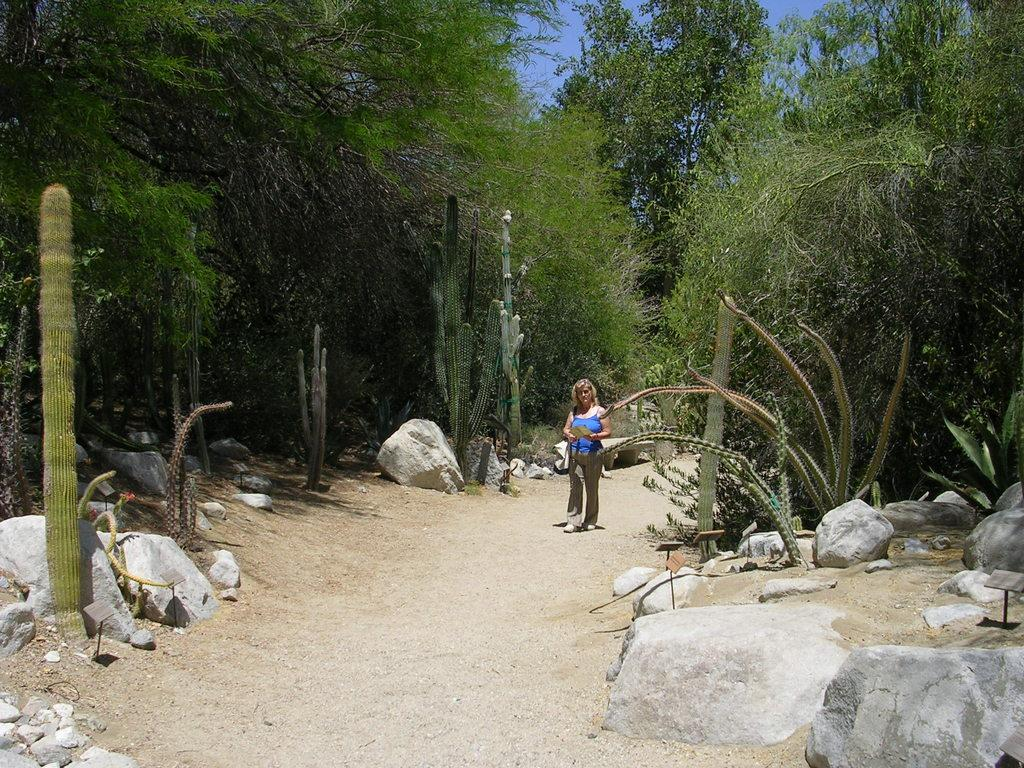Who is present in the image? There is a woman in the image. What type of natural elements can be seen in the image? There are trees, plants, and stones visible in the image. What type of terrain is visible in the image? There is land visible in the image. What part of the natural environment is visible in the image? The sky is visible in the image. What type of thread is being used by the woman to sleep in the image? There is no thread or sleeping activity present in the image. 